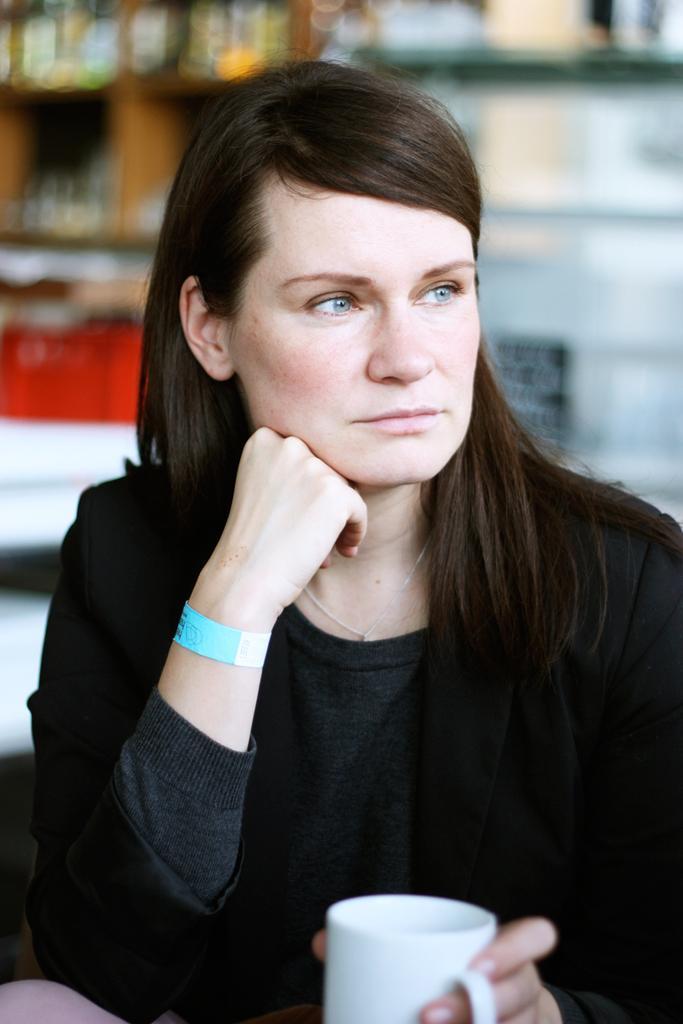Can you describe this image briefly? In this image we can see a woman she is holding a cup in her hand. 